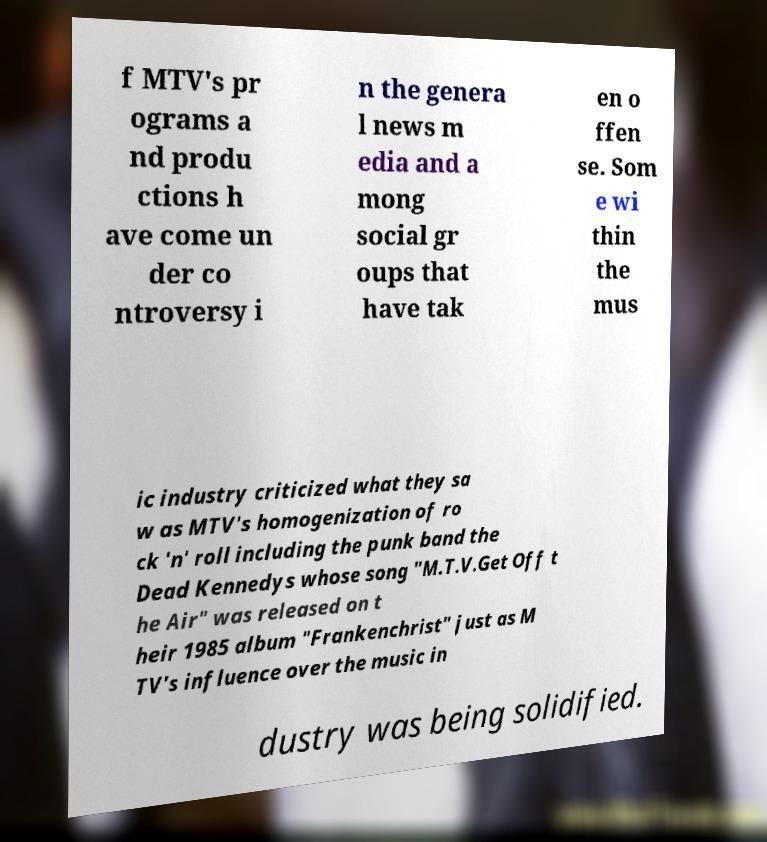Can you read and provide the text displayed in the image?This photo seems to have some interesting text. Can you extract and type it out for me? f MTV's pr ograms a nd produ ctions h ave come un der co ntroversy i n the genera l news m edia and a mong social gr oups that have tak en o ffen se. Som e wi thin the mus ic industry criticized what they sa w as MTV's homogenization of ro ck 'n' roll including the punk band the Dead Kennedys whose song "M.T.V.Get Off t he Air" was released on t heir 1985 album "Frankenchrist" just as M TV's influence over the music in dustry was being solidified. 